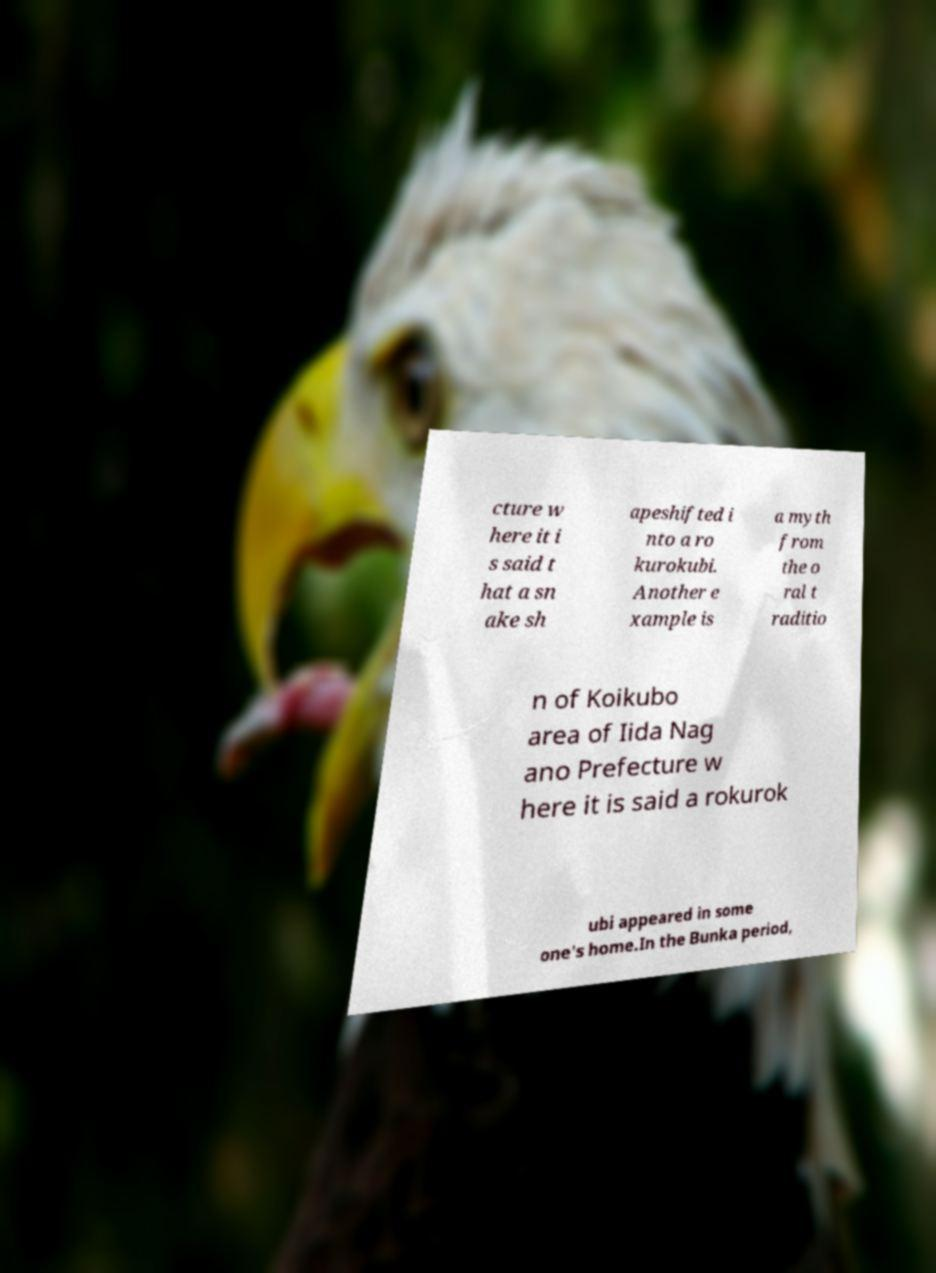Can you accurately transcribe the text from the provided image for me? cture w here it i s said t hat a sn ake sh apeshifted i nto a ro kurokubi. Another e xample is a myth from the o ral t raditio n of Koikubo area of Iida Nag ano Prefecture w here it is said a rokurok ubi appeared in some one's home.In the Bunka period, 